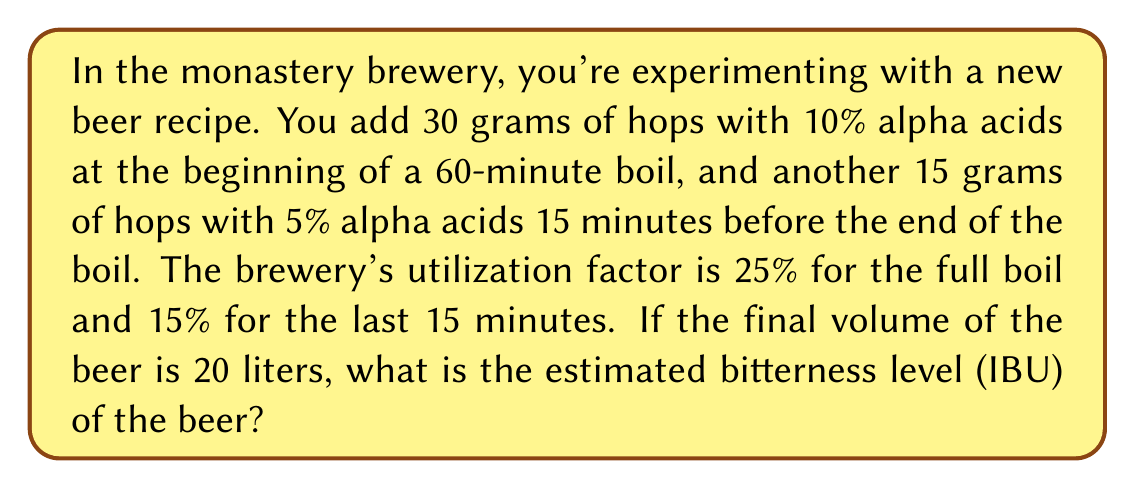Could you help me with this problem? To solve this problem, we'll use the formula for calculating IBUs:

$$IBU = \frac{\text{Hop weight (g)} \times \text{Alpha acid (%)} \times \text{Utilization (%)} \times 1000}{\text{Volume (L)}}$$

Let's calculate the IBUs for each hop addition:

1. First hop addition (60-minute boil):
   $$IBU_1 = \frac{30 \text{ g} \times 10\% \times 25\% \times 1000}{20 \text{ L}} = 37.5$$

2. Second hop addition (15-minute boil):
   $$IBU_2 = \frac{15 \text{ g} \times 5\% \times 15\% \times 1000}{20 \text{ L}} = 5.625$$

3. Total IBUs:
   $$IBU_{total} = IBU_1 + IBU_2 = 37.5 + 5.625 = 43.125$$

Therefore, the estimated bitterness level of the beer is 43.125 IBUs.
Answer: 43.125 IBUs 